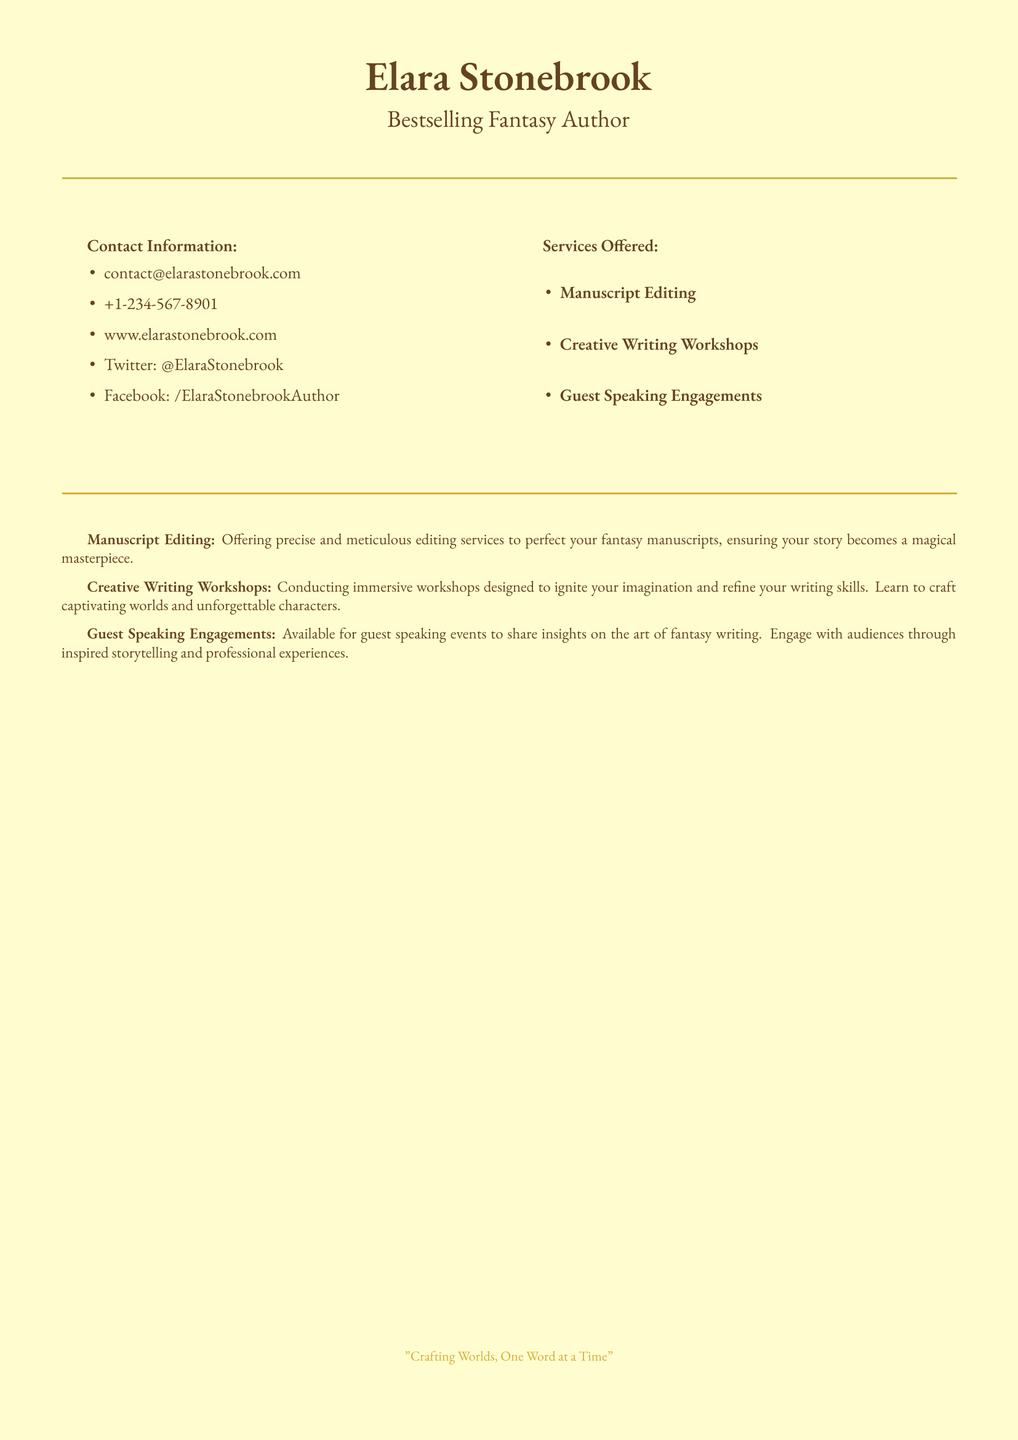What is the author's name? The author's name is prominently displayed at the top of the business card.
Answer: Elara Stonebrook What is the main occupation of Elara Stonebrook? The occupation listed below the name indicates her professional focus.
Answer: Bestselling Fantasy Author What is the contact email provided? The email is listed under the contact information section.
Answer: contact@elarastonebrook.com How many services are offered? The number of services is found by counting the items listed under services offered.
Answer: Three What type of workshops does Elara Stonebrook conduct? The type of workshops is detailed in the section about services.
Answer: Creative Writing Workshops What is the quote included at the bottom of the card? The quote is a signature phrase that reflects the author's philosophy on writing.
Answer: "Crafting Worlds, One Word at a Time" What color is the background of the business card? The background color is specified at the start of the document.
Answer: Parchment Which social media platform is mentioned? The social media platform is indicated in the contact information section.
Answer: Twitter What is a key aspect of the manuscript editing service? A defining characteristic of the editing service is noted in its description.
Answer: Precise and meticulous editing services 